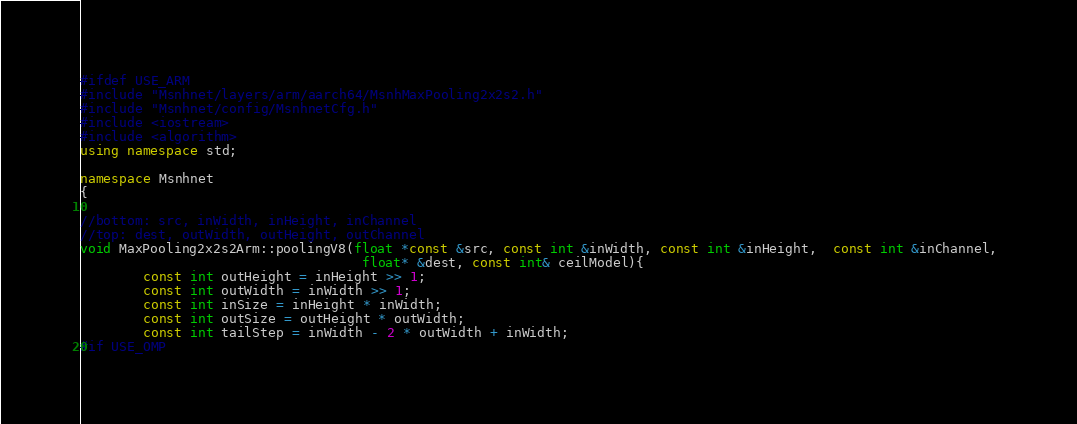<code> <loc_0><loc_0><loc_500><loc_500><_C++_>#ifdef USE_ARM
#include "Msnhnet/layers/arm/aarch64/MsnhMaxPooling2x2s2.h"
#include "Msnhnet/config/MsnhnetCfg.h"
#include <iostream>
#include <algorithm>
using namespace std;

namespace Msnhnet
{

//bottom: src, inWidth, inHeight, inChannel
//top: dest, outWidth, outHeight, outChannel
void MaxPooling2x2s2Arm::poolingV8(float *const &src, const int &inWidth, const int &inHeight,  const int &inChannel, 
                                    float* &dest, const int& ceilModel){
        const int outHeight = inHeight >> 1;
        const int outWidth = inWidth >> 1;
        const int inSize = inHeight * inWidth;
        const int outSize = outHeight * outWidth;
        const int tailStep = inWidth - 2 * outWidth + inWidth;
#if USE_OMP</code> 